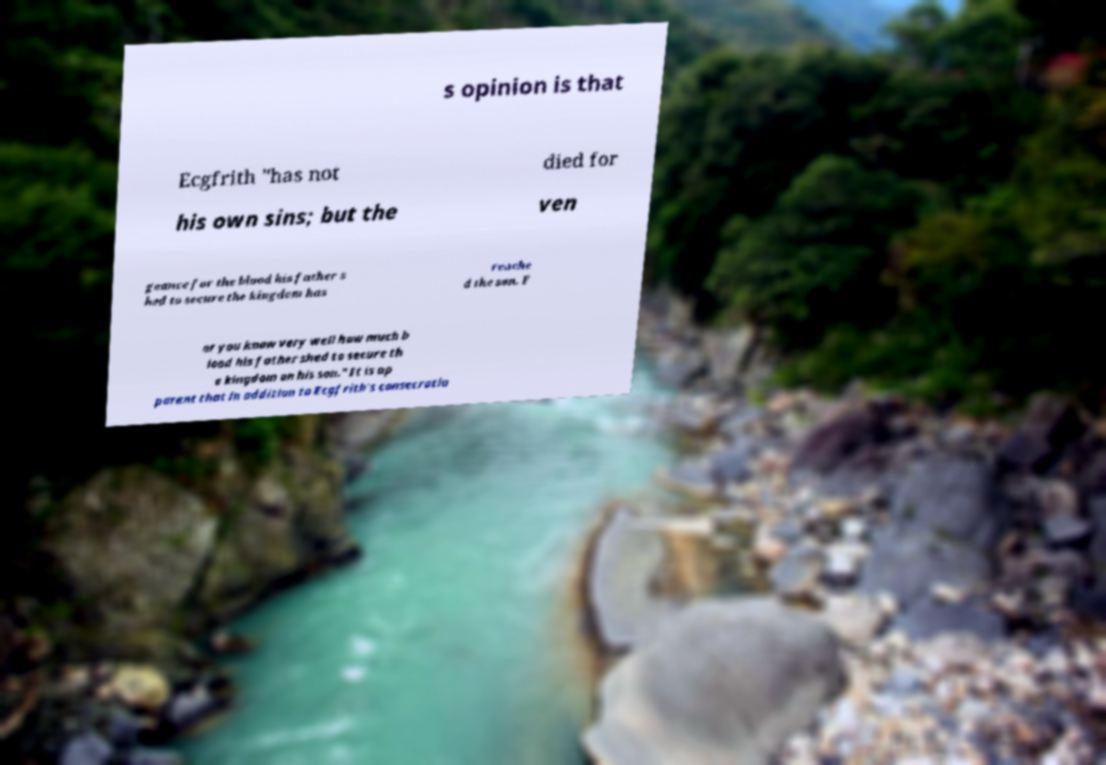Please read and relay the text visible in this image. What does it say? s opinion is that Ecgfrith "has not died for his own sins; but the ven geance for the blood his father s hed to secure the kingdom has reache d the son. F or you know very well how much b lood his father shed to secure th e kingdom on his son." It is ap parent that in addition to Ecgfrith's consecratio 